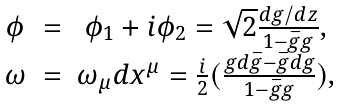<formula> <loc_0><loc_0><loc_500><loc_500>\begin{array} { c c c } \phi & = & \phi _ { 1 } + i \phi _ { 2 } = \sqrt { 2 } \frac { d g / d z } { 1 - \bar { g } g } , \\ \omega & = & \omega _ { \mu } d x ^ { \mu } = \frac { i } { 2 } ( \frac { g d \bar { g } - \bar { g } d g } { 1 - \bar { g } g } ) , \end{array}</formula> 